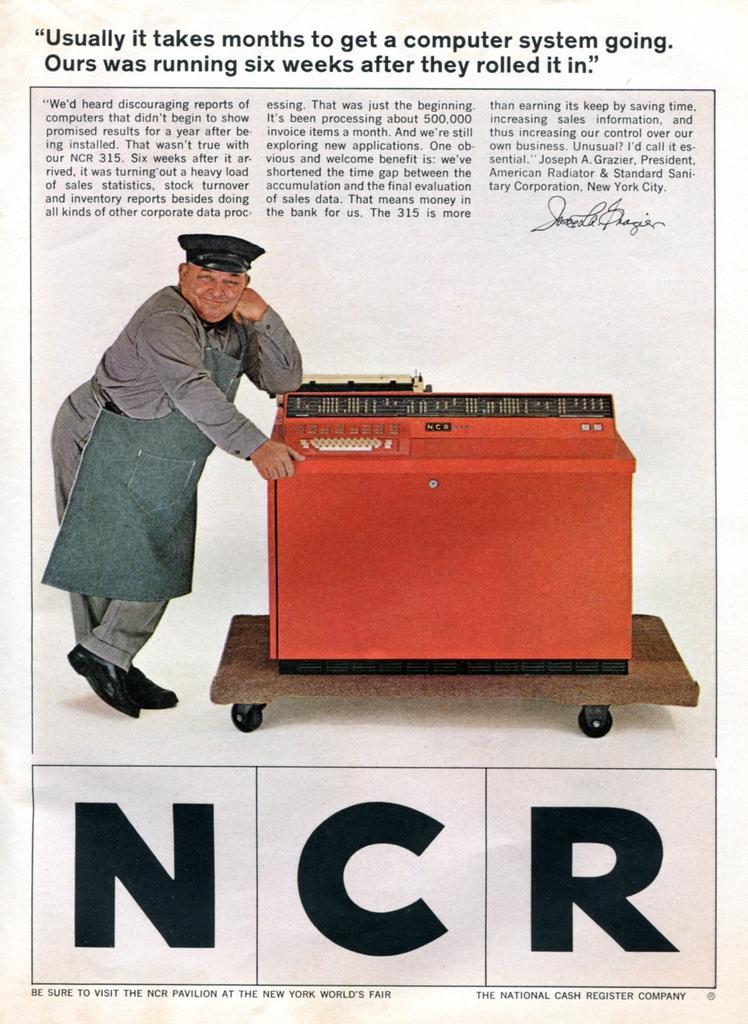Describe this image in one or two sentences. It is a newspaper in this a man is standing and this is a machine which is in red color. 